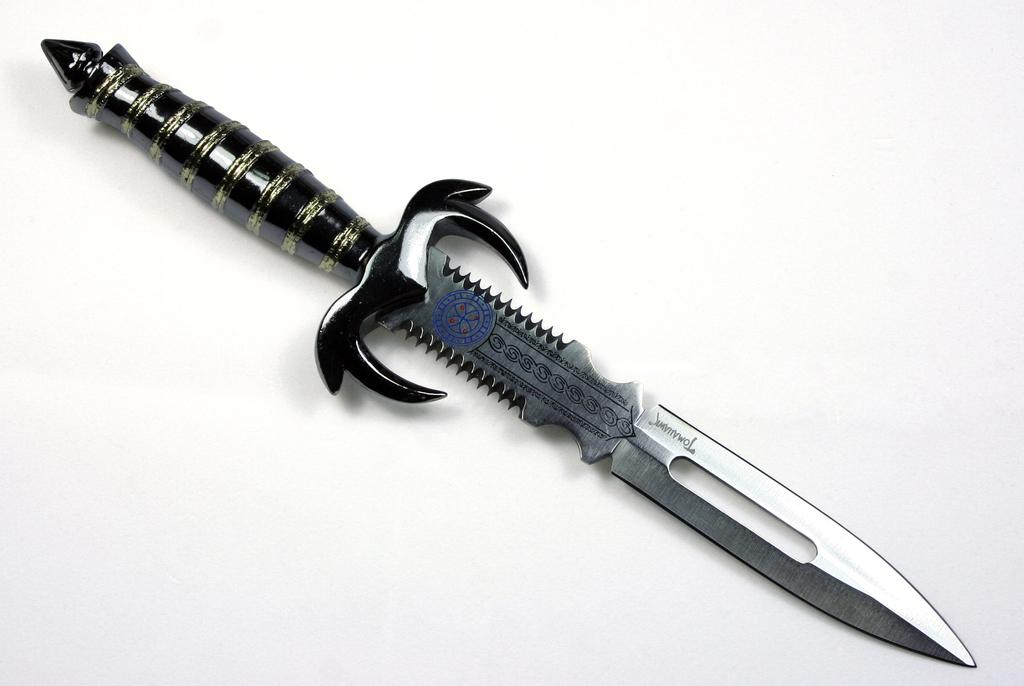What object can be seen in the image with a black handle? There is a knife in the image with a black color handle. What is the color of the surface where the knife is placed? The knife is placed on a white color surface. How many beginner snakes are visible in the image? There are no snakes, beginner or otherwise, visible in the image. The image only features a knife with a black handle placed on a white surface. 